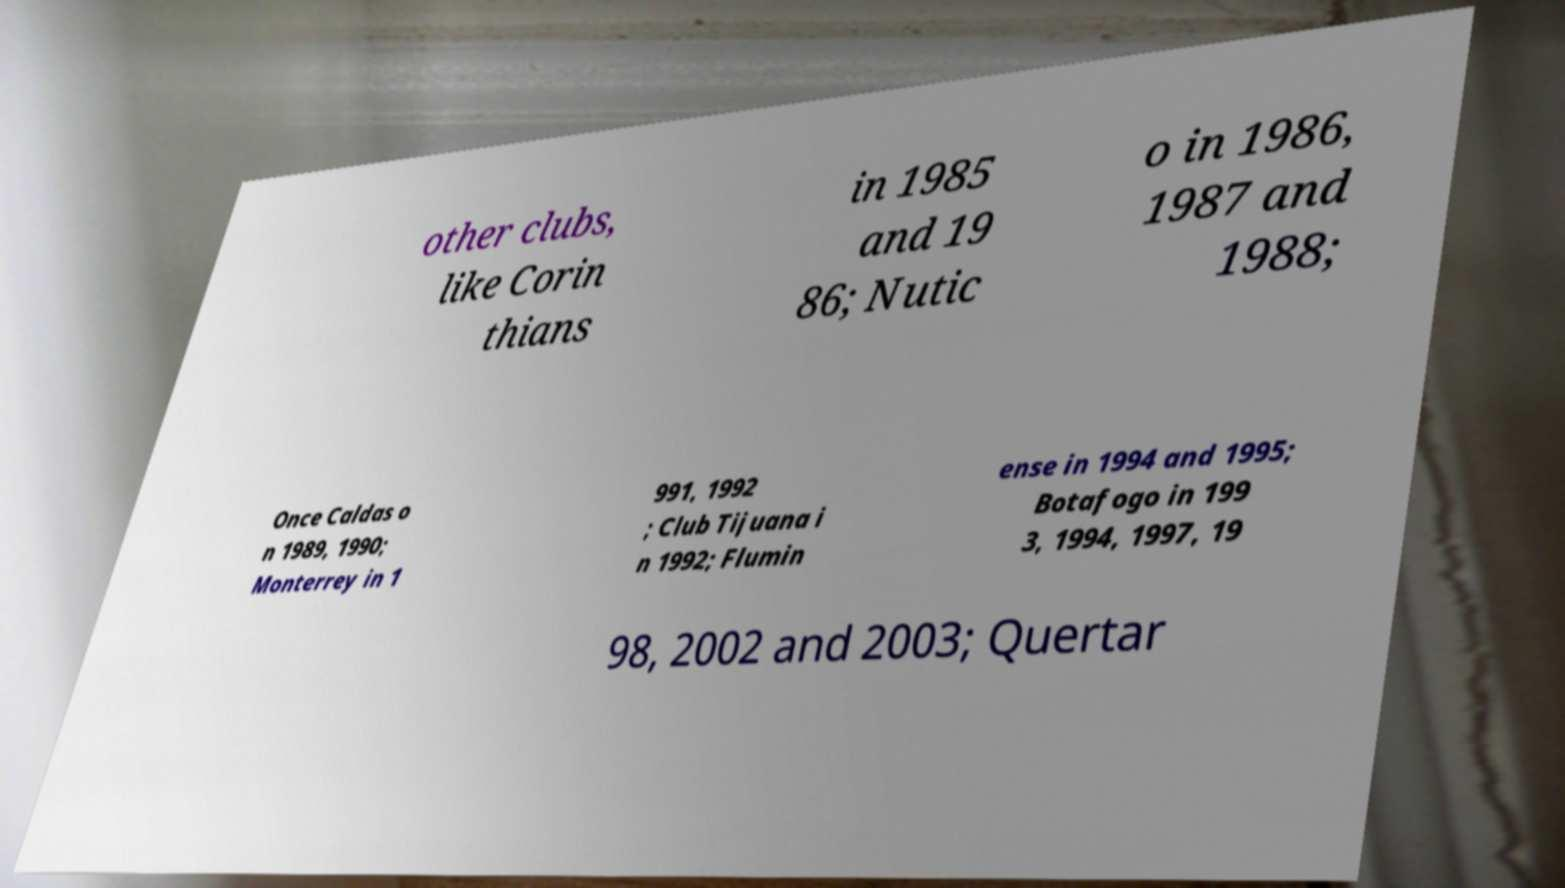Can you accurately transcribe the text from the provided image for me? other clubs, like Corin thians in 1985 and 19 86; Nutic o in 1986, 1987 and 1988; Once Caldas o n 1989, 1990; Monterrey in 1 991, 1992 ; Club Tijuana i n 1992; Flumin ense in 1994 and 1995; Botafogo in 199 3, 1994, 1997, 19 98, 2002 and 2003; Quertar 